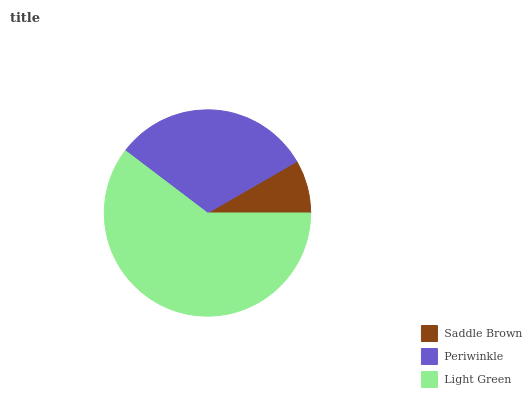Is Saddle Brown the minimum?
Answer yes or no. Yes. Is Light Green the maximum?
Answer yes or no. Yes. Is Periwinkle the minimum?
Answer yes or no. No. Is Periwinkle the maximum?
Answer yes or no. No. Is Periwinkle greater than Saddle Brown?
Answer yes or no. Yes. Is Saddle Brown less than Periwinkle?
Answer yes or no. Yes. Is Saddle Brown greater than Periwinkle?
Answer yes or no. No. Is Periwinkle less than Saddle Brown?
Answer yes or no. No. Is Periwinkle the high median?
Answer yes or no. Yes. Is Periwinkle the low median?
Answer yes or no. Yes. Is Saddle Brown the high median?
Answer yes or no. No. Is Saddle Brown the low median?
Answer yes or no. No. 